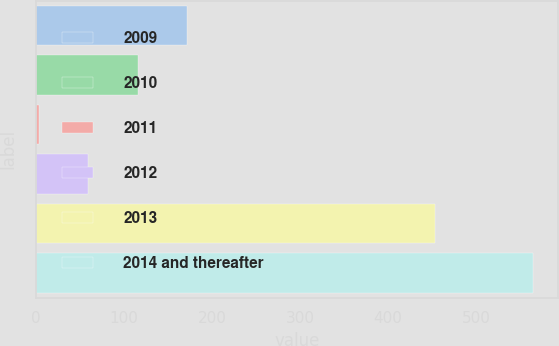<chart> <loc_0><loc_0><loc_500><loc_500><bar_chart><fcel>2009<fcel>2010<fcel>2011<fcel>2012<fcel>2013<fcel>2014 and thereafter<nl><fcel>171.6<fcel>115.4<fcel>3<fcel>59.2<fcel>453<fcel>565<nl></chart> 